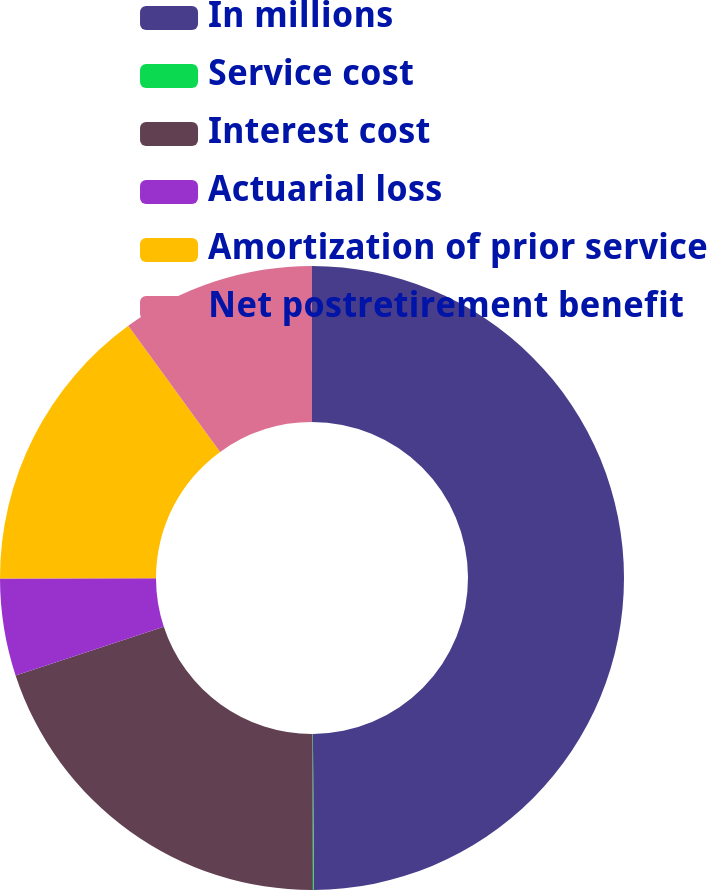Convert chart to OTSL. <chart><loc_0><loc_0><loc_500><loc_500><pie_chart><fcel>In millions<fcel>Service cost<fcel>Interest cost<fcel>Actuarial loss<fcel>Amortization of prior service<fcel>Net postretirement benefit<nl><fcel>49.9%<fcel>0.05%<fcel>19.99%<fcel>5.03%<fcel>15.0%<fcel>10.02%<nl></chart> 